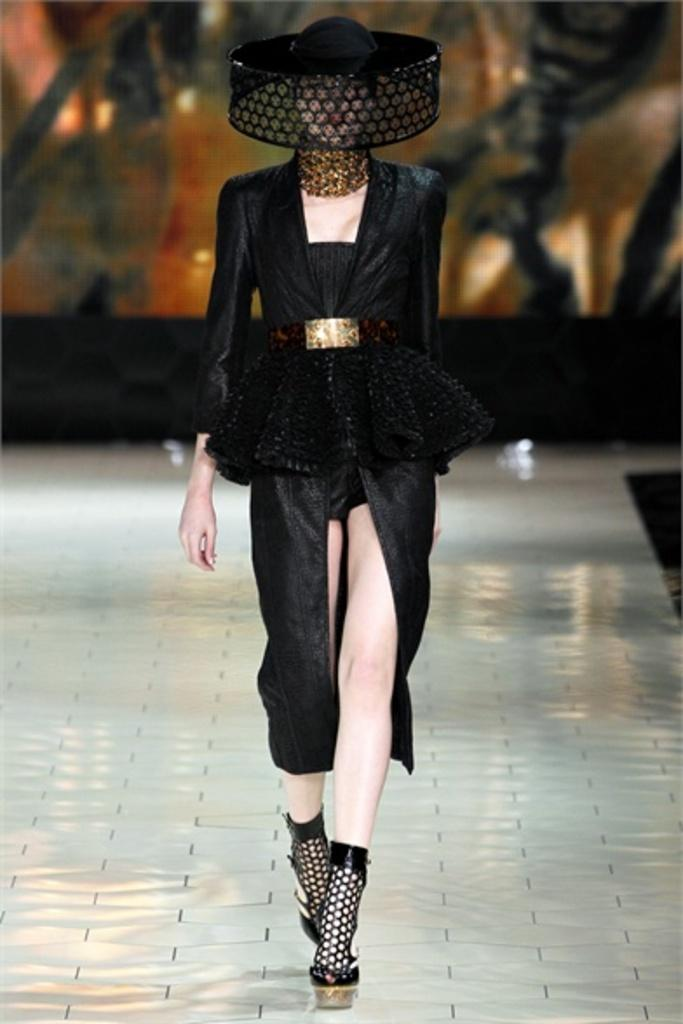Who is present in the image? There is a woman in the image. What is the woman wearing? The woman is wearing a black dress and a hat. What type of footwear is the woman wearing? The woman is wearing footwear, but the specific type is not mentioned in the facts. What is the color of the surface the woman is walking on? The surface she is walking on is silver in color. What type of bit is the woman using to eat her food in the image? There is no mention of the woman eating food or using a bit in the image. 